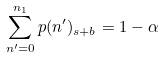<formula> <loc_0><loc_0><loc_500><loc_500>\sum _ { n ^ { \prime } = 0 } ^ { n _ { 1 } } p ( n ^ { \prime } ) _ { s + b } = 1 - \alpha</formula> 